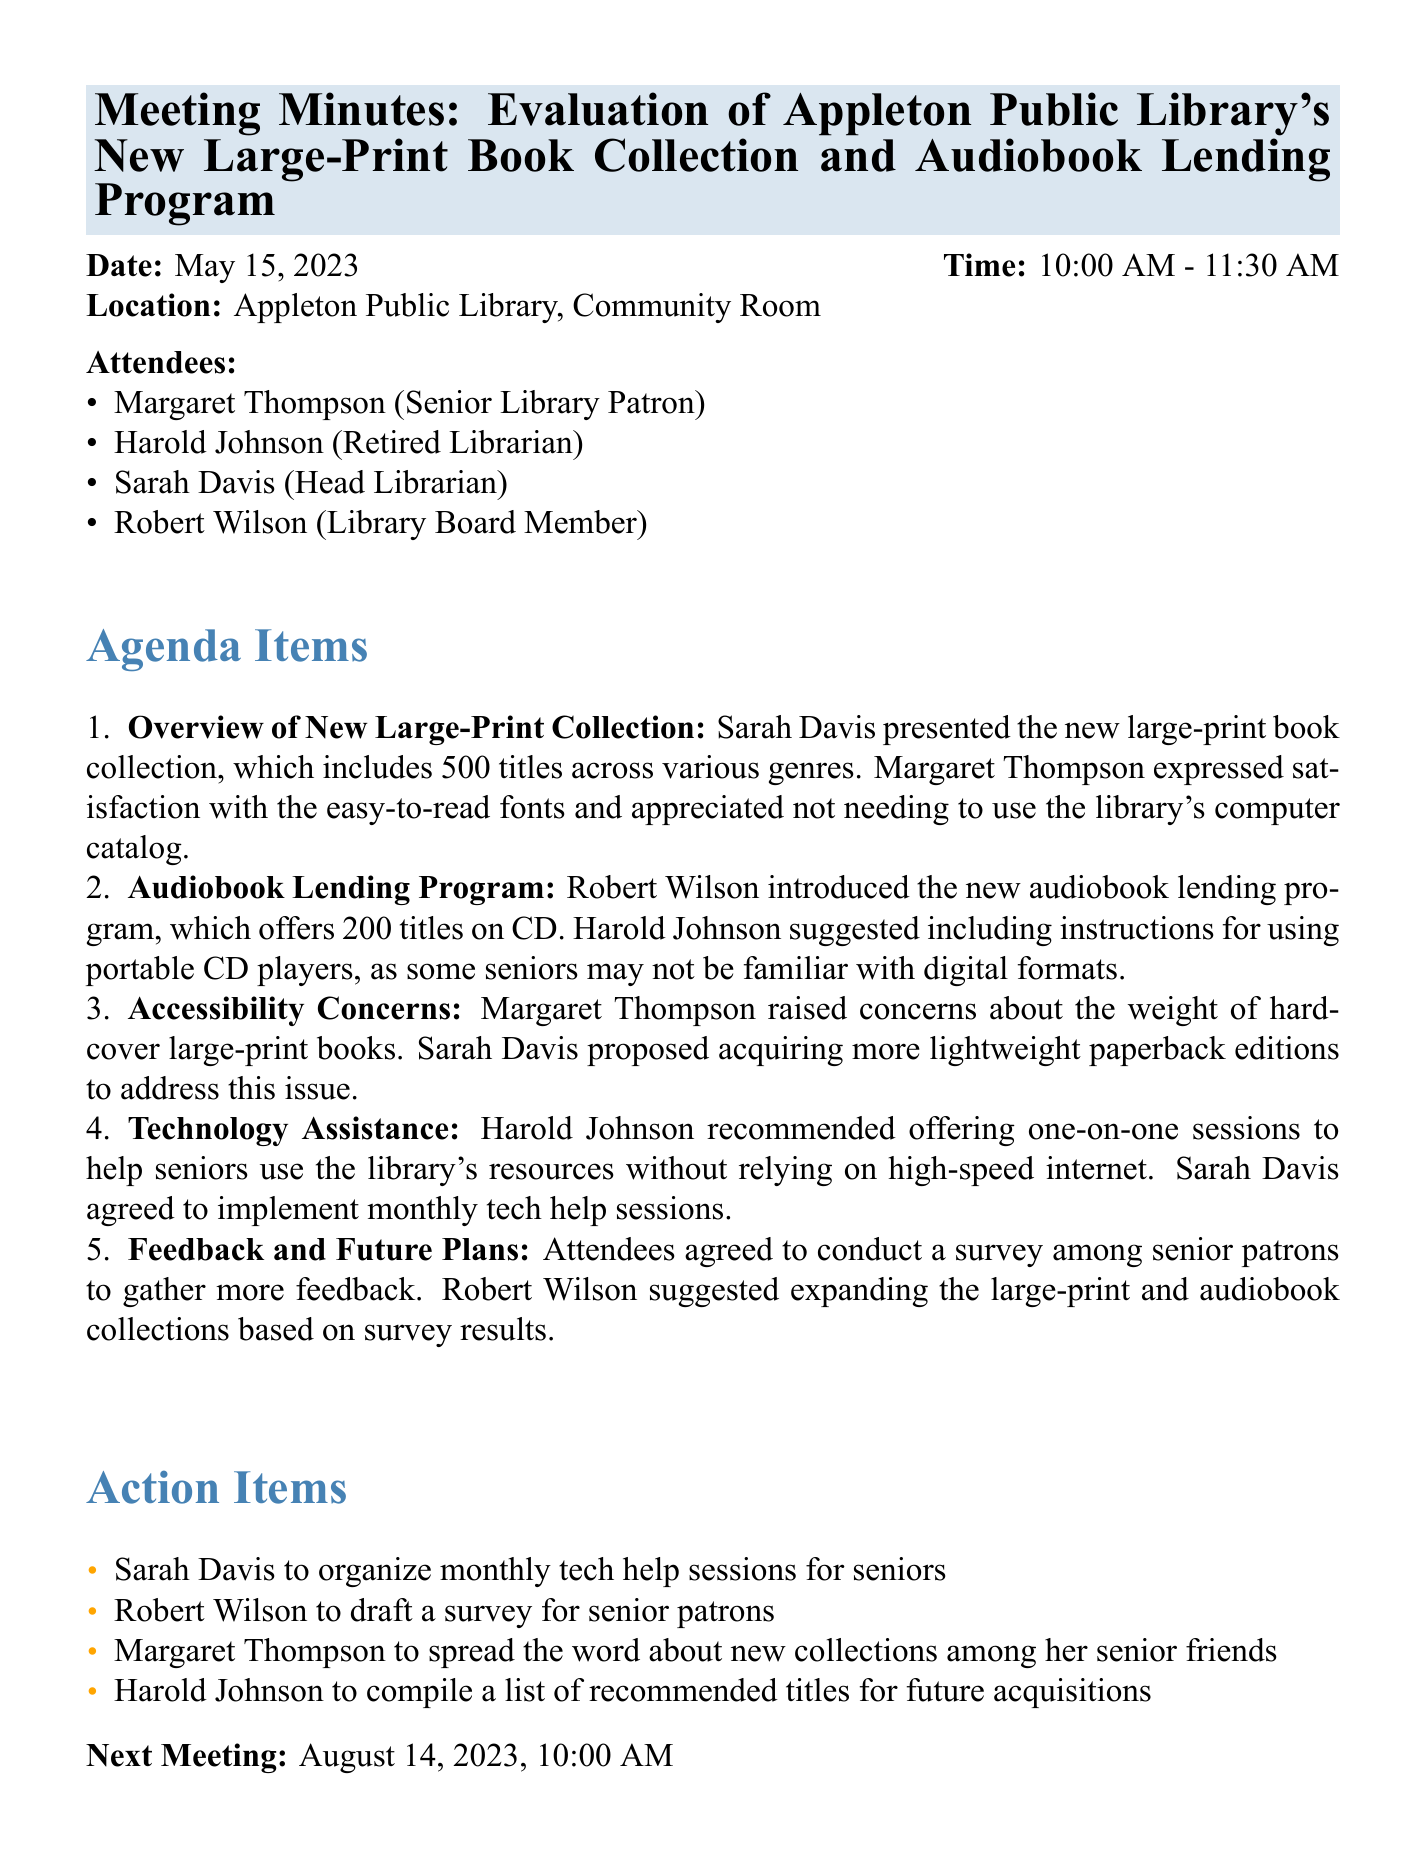What is the title of the meeting? The title of the meeting is provided in the document's heading.
Answer: Evaluation of Appleton Public Library's New Large-Print Book Collection and Audiobook Lending Program What date did the meeting take place? The meeting date is stated in the document.
Answer: May 15, 2023 Who expressed satisfaction with the easy-to-read fonts? This information is found in the discussion about the large-print collection.
Answer: Margaret Thompson How many titles are included in the new audiobook lending program? This is specified under the agenda item regarding the audiobook lending program.
Answer: 200 titles What action item involves spreading the word to senior friends? The action items list names who is responsible for different tasks.
Answer: Margaret Thompson What was proposed to address the weight of hardcover large-print books? This question pertains to the accessibility concerns raised during the meeting.
Answer: Acquire more lightweight paperback editions When is the next meeting scheduled? The next meeting date is provided at the end of the document.
Answer: August 14, 2023 What did Harold Johnson recommend for seniors regarding technology? This refers to the technology assistance discussion in the meeting.
Answer: Offering one-on-one sessions Which attendee is the Head Librarian? This information is found in the list of attendees.
Answer: Sarah Davis 